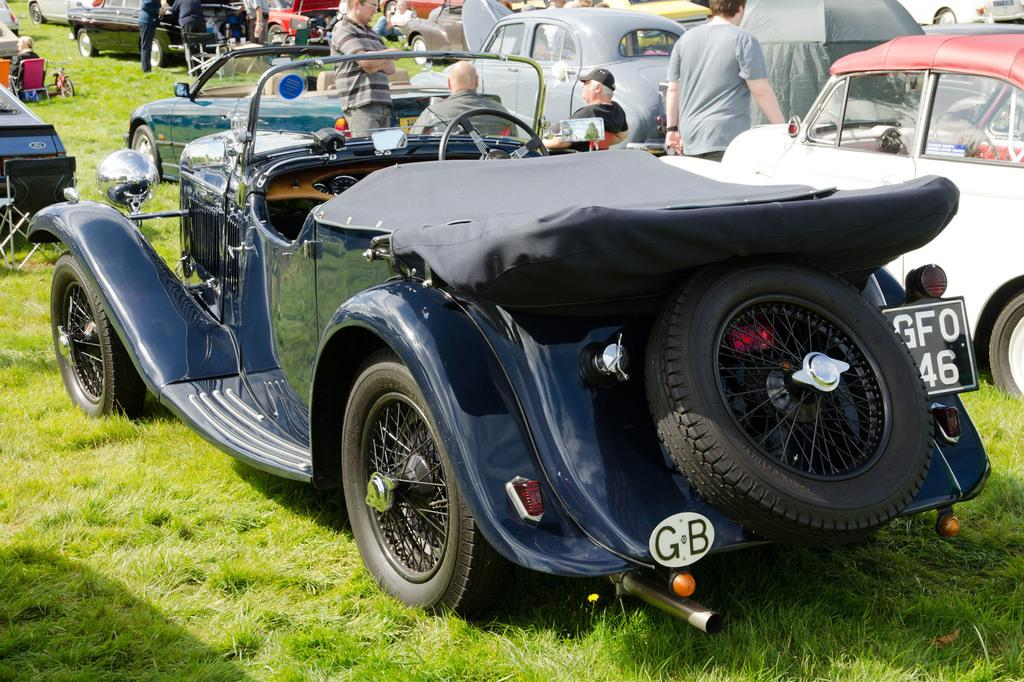What types of objects are present in the image? There are vehicles in the image. Can you describe the appearance of the vehicles? The vehicles have different colors. What are the people in the image doing? There are people standing and sitting in the image. What type of vegetation can be seen in the image? There is green color grass visible in the image. Where is the crate located in the image? There is no crate present in the image. What type of road can be seen in the image? There is no road visible in the image. 